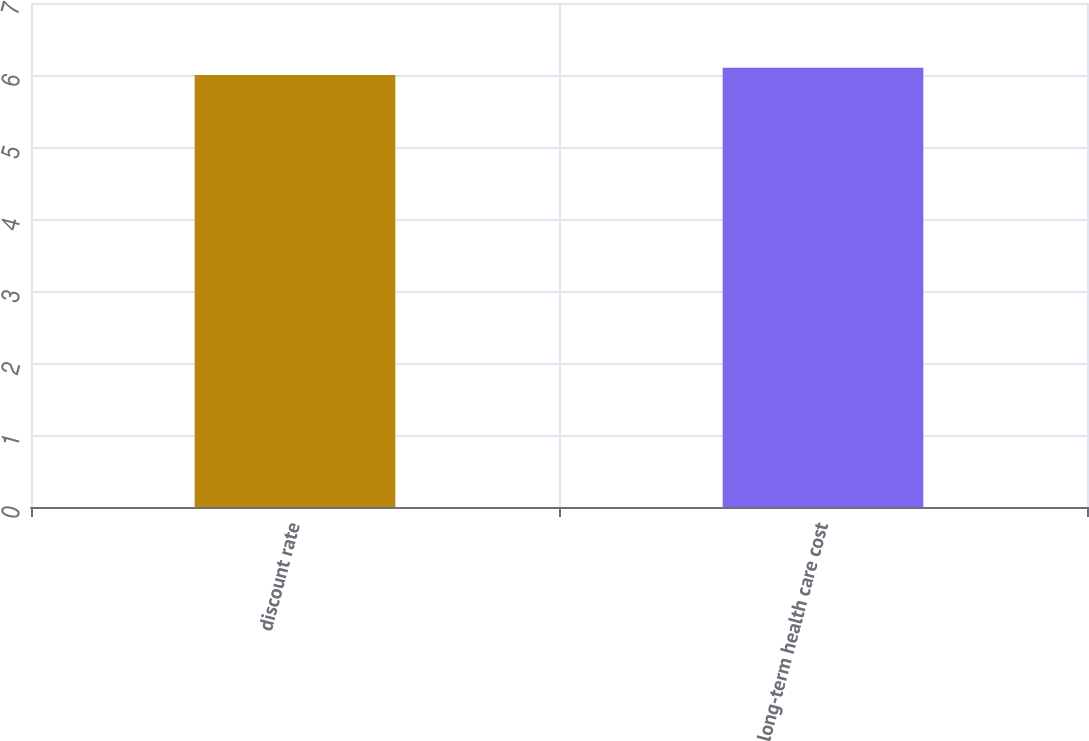Convert chart to OTSL. <chart><loc_0><loc_0><loc_500><loc_500><bar_chart><fcel>discount rate<fcel>long-term health care cost<nl><fcel>6<fcel>6.1<nl></chart> 